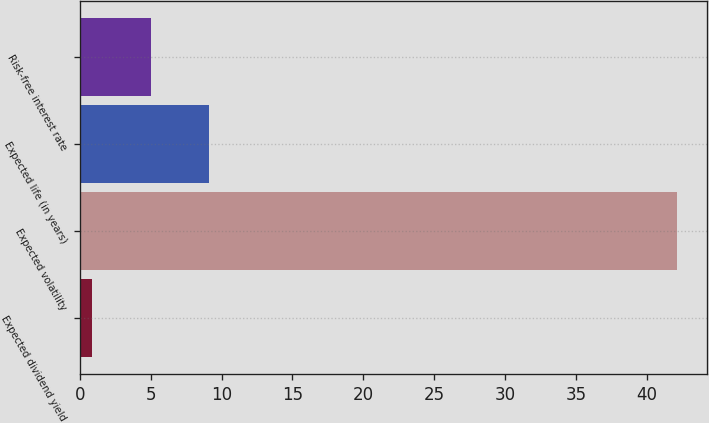<chart> <loc_0><loc_0><loc_500><loc_500><bar_chart><fcel>Expected dividend yield<fcel>Expected volatility<fcel>Expected life (in years)<fcel>Risk-free interest rate<nl><fcel>0.87<fcel>42.17<fcel>9.13<fcel>5<nl></chart> 